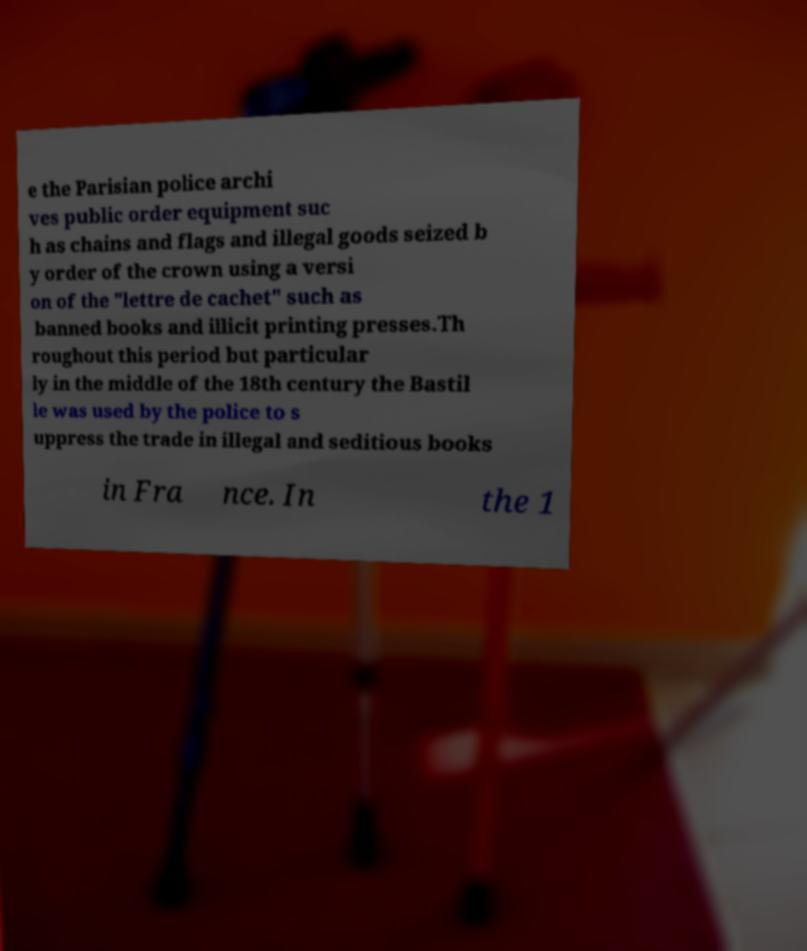There's text embedded in this image that I need extracted. Can you transcribe it verbatim? e the Parisian police archi ves public order equipment suc h as chains and flags and illegal goods seized b y order of the crown using a versi on of the "lettre de cachet" such as banned books and illicit printing presses.Th roughout this period but particular ly in the middle of the 18th century the Bastil le was used by the police to s uppress the trade in illegal and seditious books in Fra nce. In the 1 